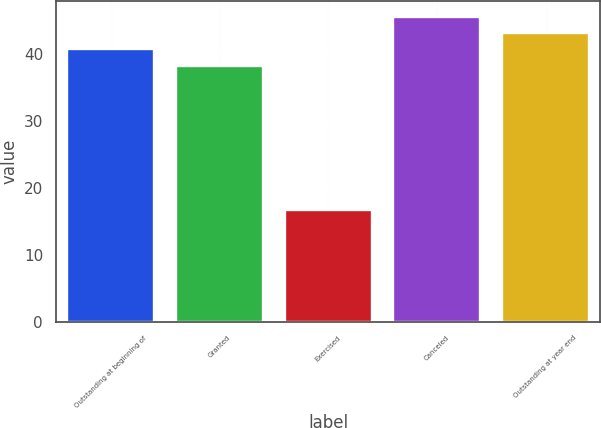Convert chart. <chart><loc_0><loc_0><loc_500><loc_500><bar_chart><fcel>Outstanding at beginning of<fcel>Granted<fcel>Exercised<fcel>Canceled<fcel>Outstanding at year end<nl><fcel>40.69<fcel>38.25<fcel>16.73<fcel>45.57<fcel>43.13<nl></chart> 